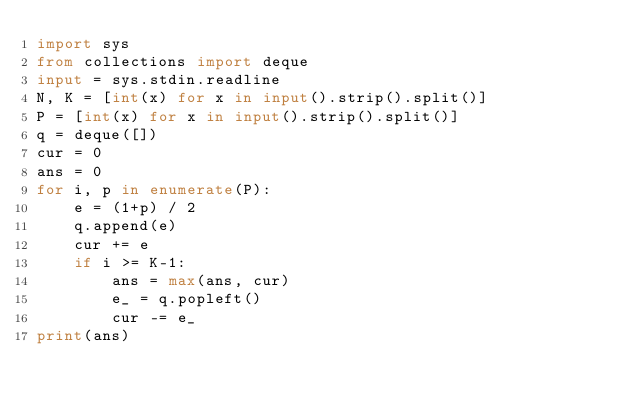Convert code to text. <code><loc_0><loc_0><loc_500><loc_500><_Python_>import sys
from collections import deque
input = sys.stdin.readline
N, K = [int(x) for x in input().strip().split()]
P = [int(x) for x in input().strip().split()]
q = deque([])
cur = 0
ans = 0
for i, p in enumerate(P):
    e = (1+p) / 2
    q.append(e)
    cur += e
    if i >= K-1:
        ans = max(ans, cur)
        e_ = q.popleft()
        cur -= e_
print(ans)</code> 